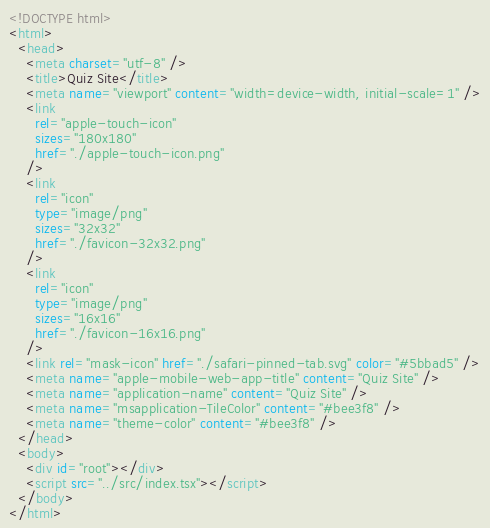<code> <loc_0><loc_0><loc_500><loc_500><_HTML_><!DOCTYPE html>
<html>
  <head>
    <meta charset="utf-8" />
    <title>Quiz Site</title>
    <meta name="viewport" content="width=device-width, initial-scale=1" />
    <link
      rel="apple-touch-icon"
      sizes="180x180"
      href="./apple-touch-icon.png"
    />
    <link
      rel="icon"
      type="image/png"
      sizes="32x32"
      href="./favicon-32x32.png"
    />
    <link
      rel="icon"
      type="image/png"
      sizes="16x16"
      href="./favicon-16x16.png"
    />
    <link rel="mask-icon" href="./safari-pinned-tab.svg" color="#5bbad5" />
    <meta name="apple-mobile-web-app-title" content="Quiz Site" />
    <meta name="application-name" content="Quiz Site" />
    <meta name="msapplication-TileColor" content="#bee3f8" />
    <meta name="theme-color" content="#bee3f8" />
  </head>
  <body>
    <div id="root"></div>
    <script src="../src/index.tsx"></script>
  </body>
</html>
</code> 